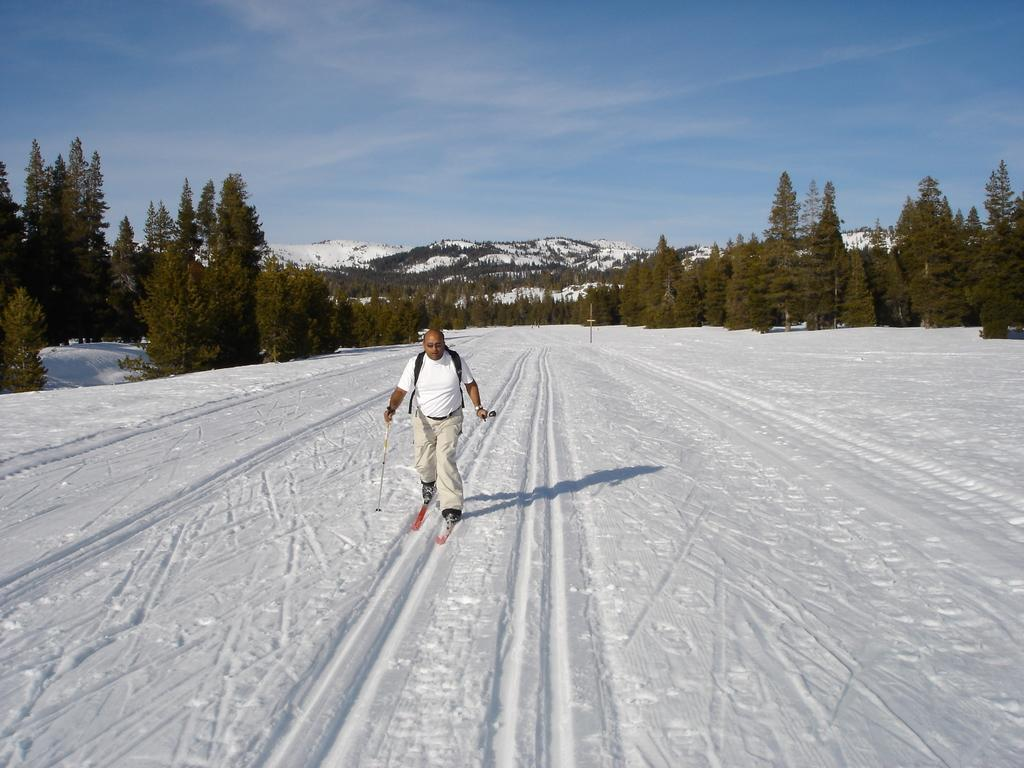What is the main activity being performed in the foreground of the picture? There is a person skiing in the foreground of the picture. What type of terrain is visible in the foreground? There is snow in the foreground. What can be seen in the center of the picture? There are trees and mountains covered with snow in the center of the picture. What is visible at the top of the image? The sky is visible at the top of the image. Where is the meeting taking place in the image? There is no meeting taking place in the image; it depicts a person skiing in a snowy environment. What type of vein can be seen running through the mountains in the image? There are no veins visible in the mountains or any other part of the image. 